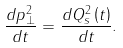Convert formula to latex. <formula><loc_0><loc_0><loc_500><loc_500>\frac { d p ^ { 2 } _ { \perp } } { d t } = \frac { d Q _ { s } ^ { 2 } \left ( t \right ) } { d t } .</formula> 